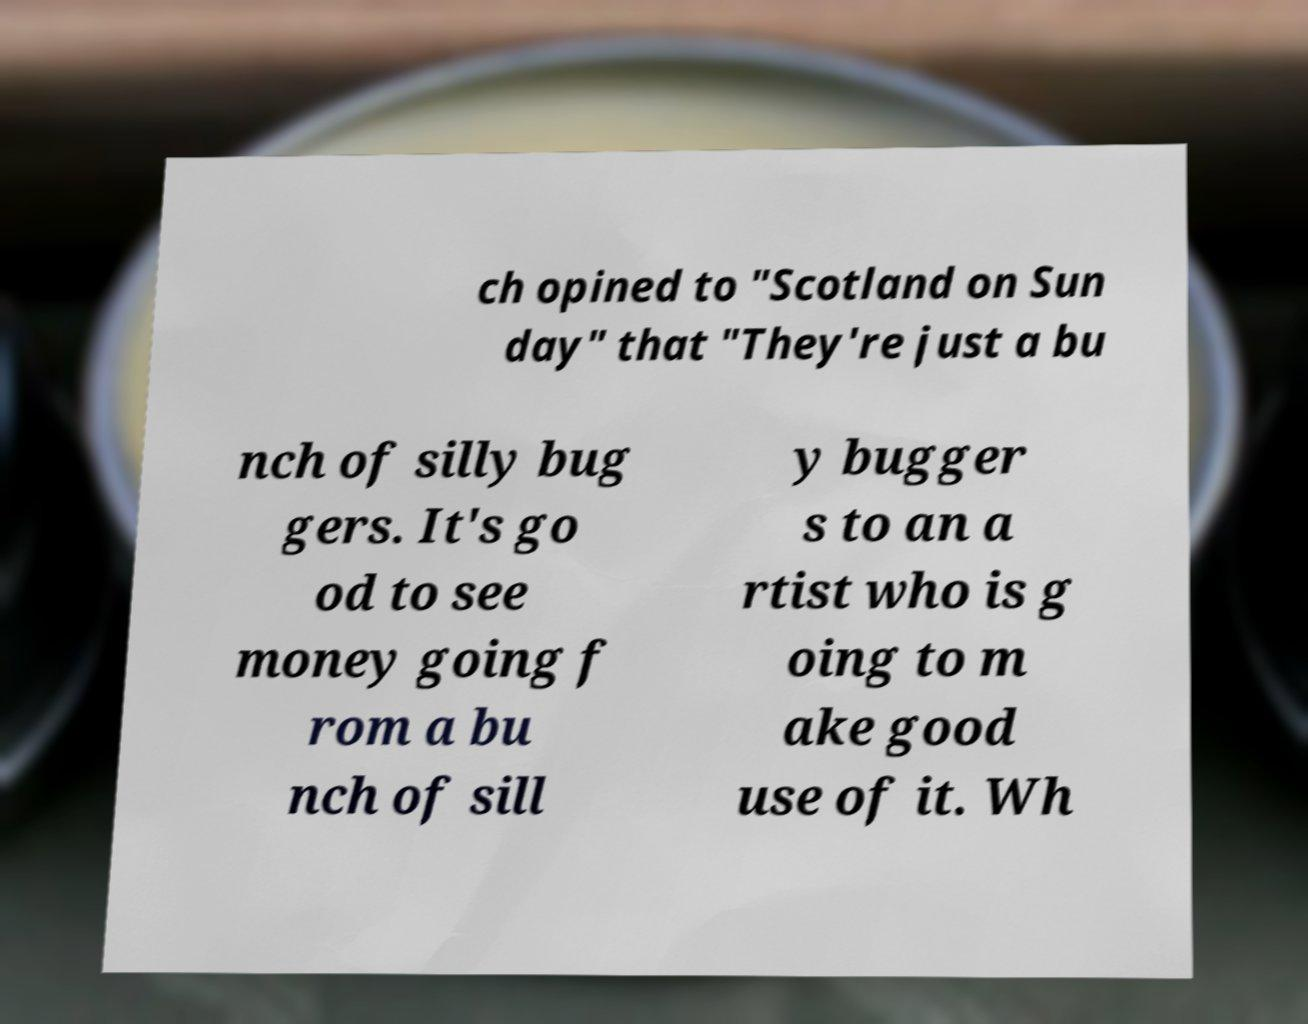Could you assist in decoding the text presented in this image and type it out clearly? ch opined to "Scotland on Sun day" that "They're just a bu nch of silly bug gers. It's go od to see money going f rom a bu nch of sill y bugger s to an a rtist who is g oing to m ake good use of it. Wh 